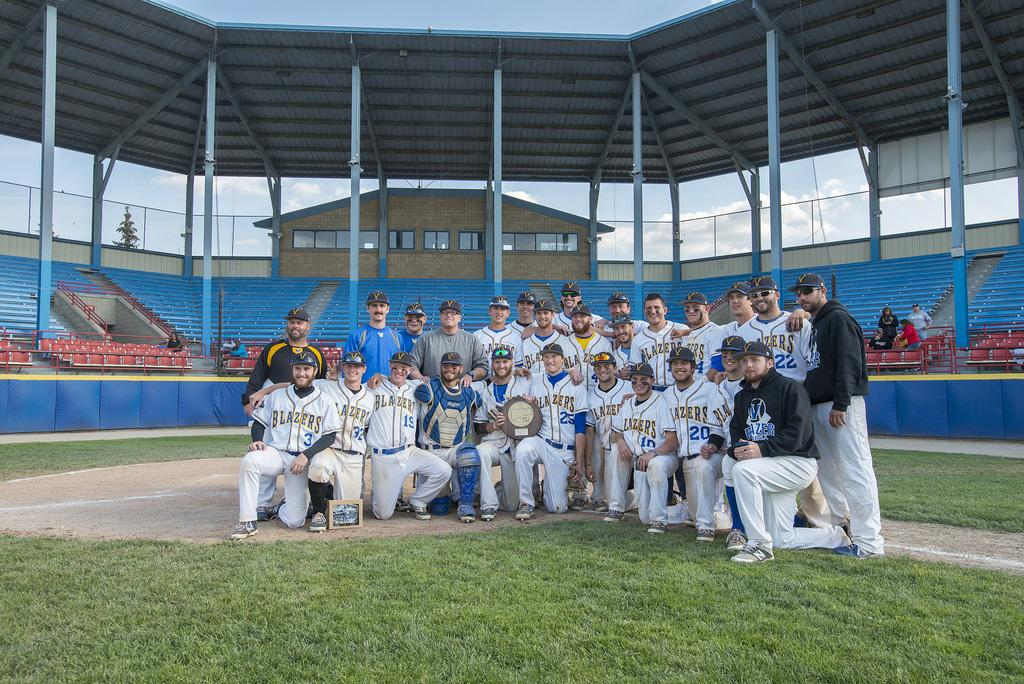<image>
Share a concise interpretation of the image provided. a team that has Blazers on their jersey sitting together 